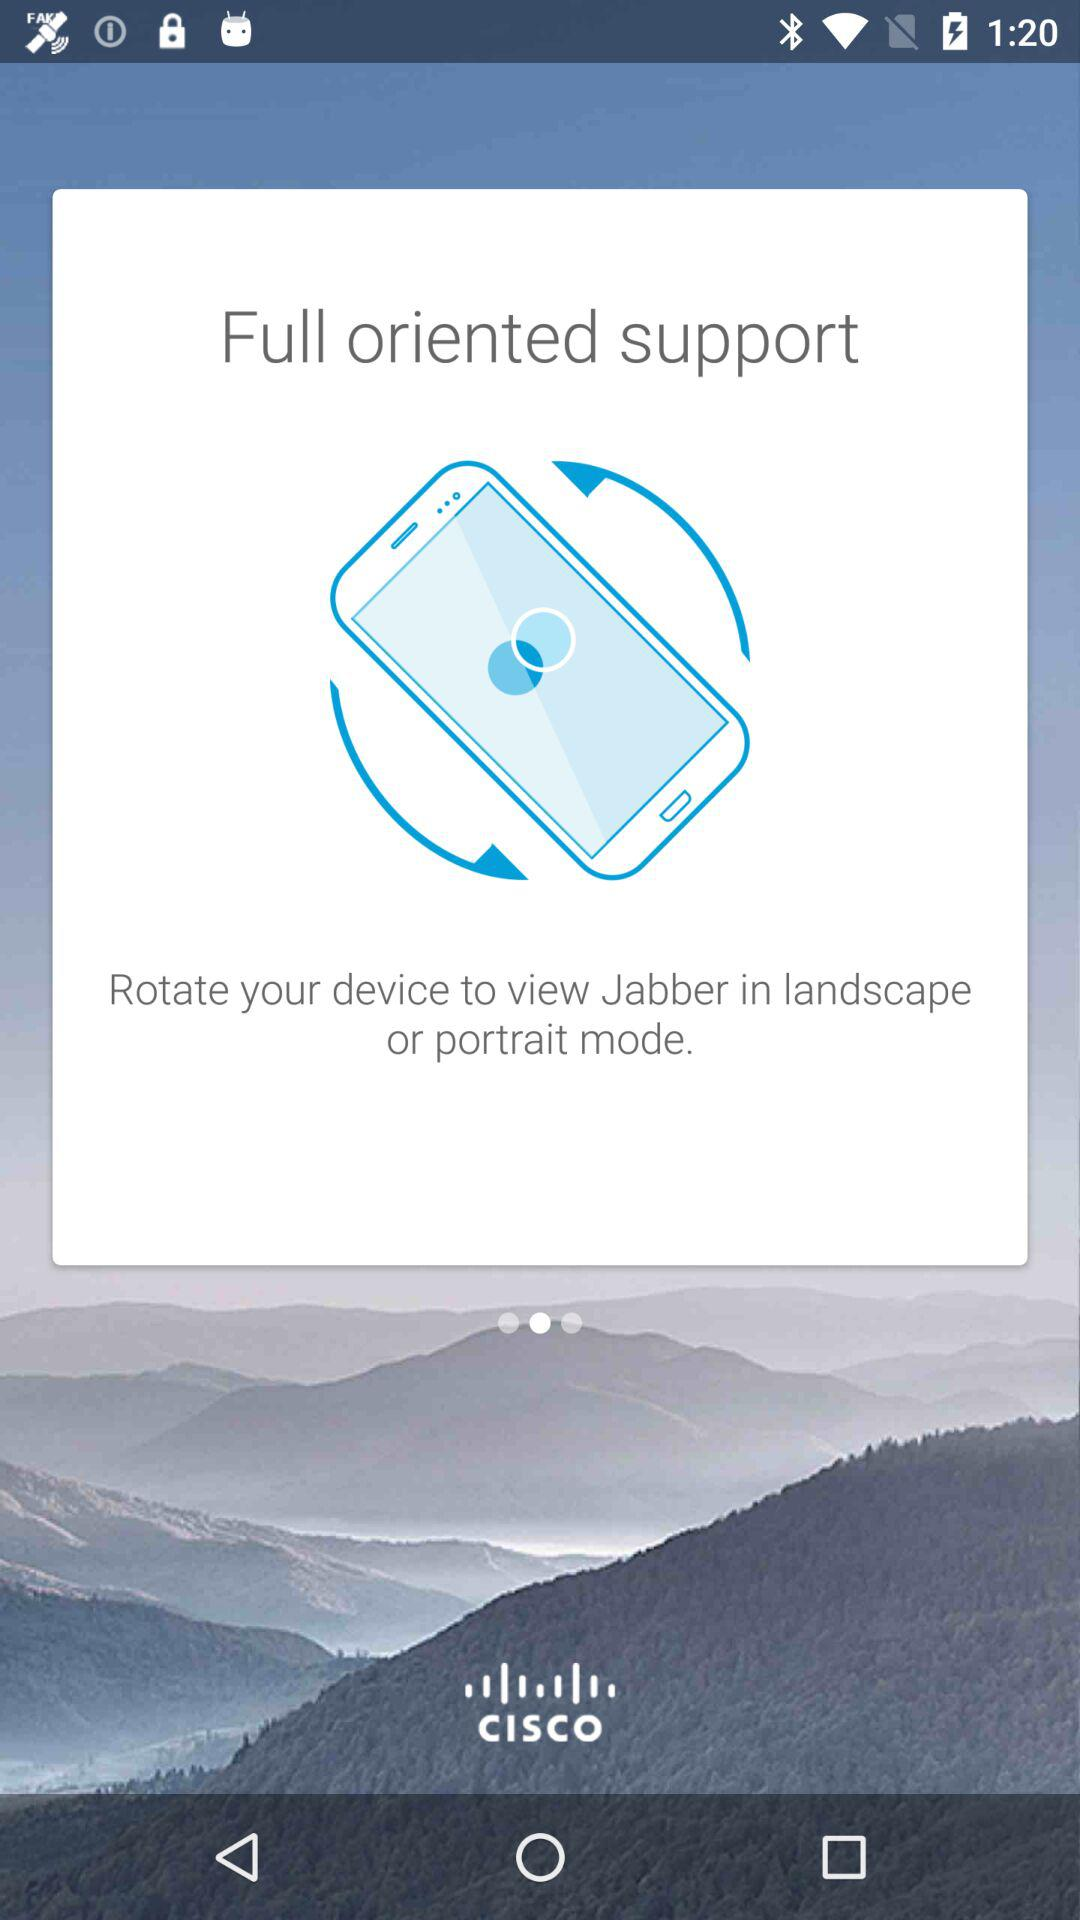Which modes are applicable for rotating the device? The applicable modes for rotating the device are landscape and portrait. 